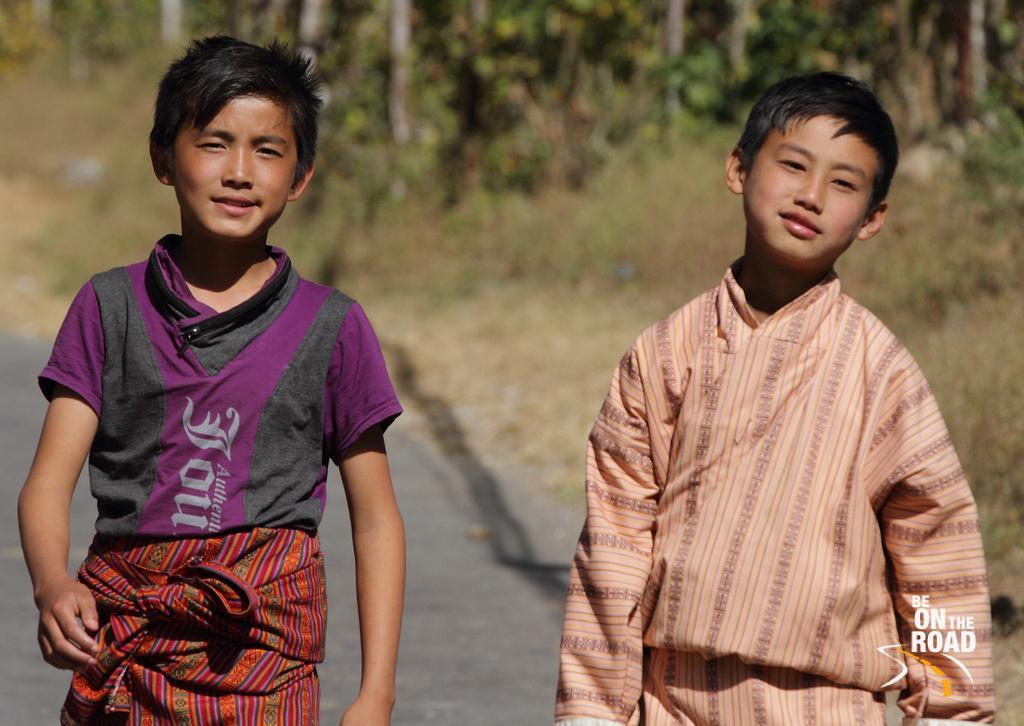In one or two sentences, can you explain what this image depicts? There are two boys standing and smiling. In the background, I can see the trees. This is the watermark on the image. 